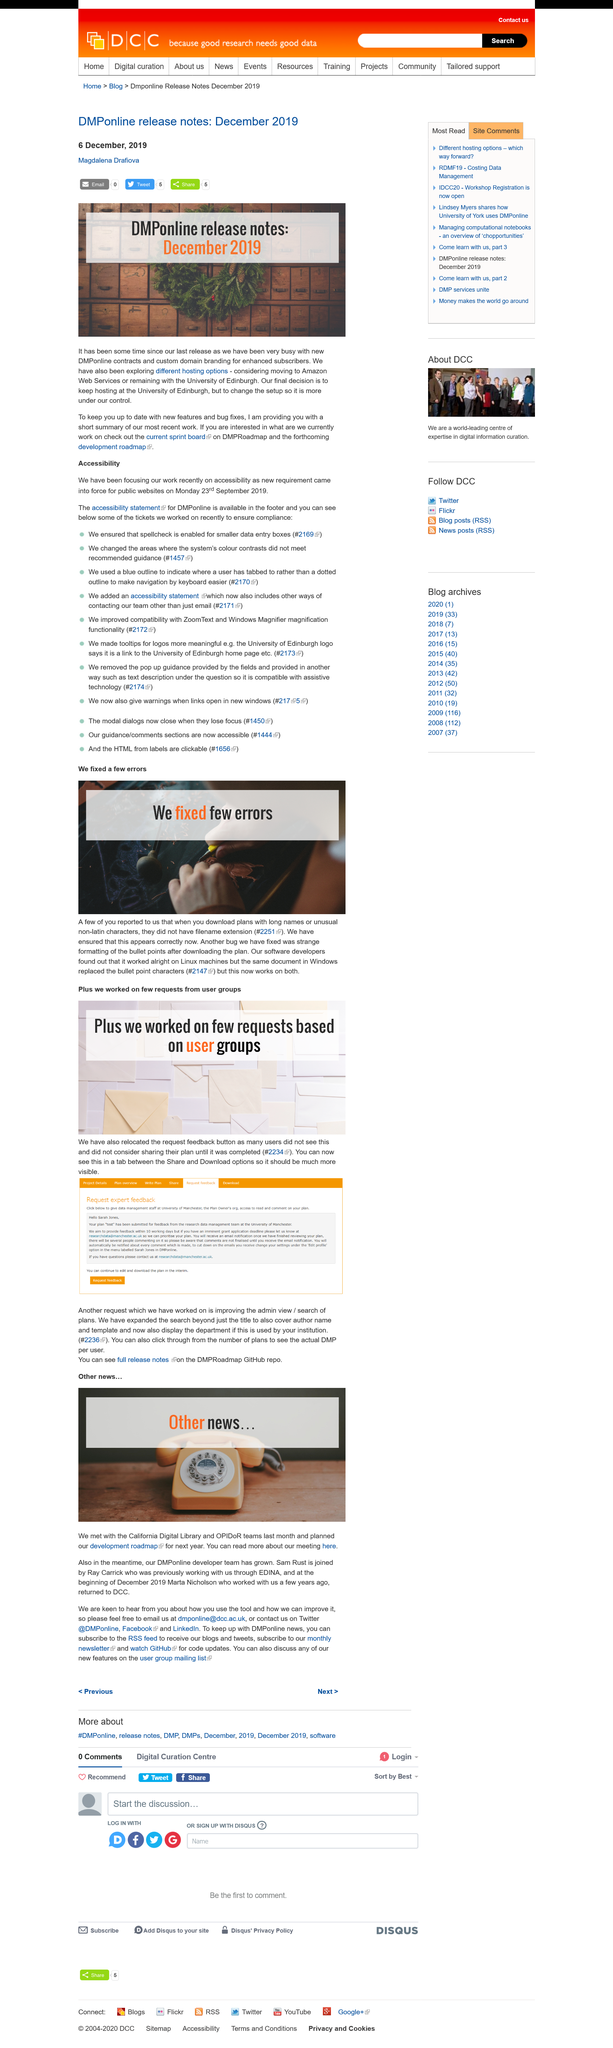List a handful of essential elements in this visual. Magdalena Drafiova wrote the DMPonline release notes in December 2019. It has been thoroughly explored whether alternative hosting options exist. The final decision was made with the aim of keeping the University of Edinburgh as the host. 